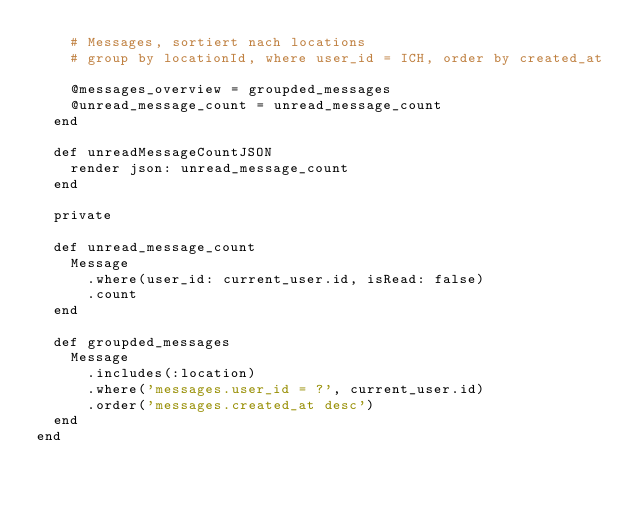<code> <loc_0><loc_0><loc_500><loc_500><_Ruby_>    # Messages, sortiert nach locations
    # group by locationId, where user_id = ICH, order by created_at

    @messages_overview = groupded_messages
    @unread_message_count = unread_message_count
  end

  def unreadMessageCountJSON
    render json: unread_message_count
  end

  private

  def unread_message_count
    Message
      .where(user_id: current_user.id, isRead: false)
      .count
  end

  def groupded_messages
    Message
      .includes(:location)
      .where('messages.user_id = ?', current_user.id)
      .order('messages.created_at desc')
  end
end
</code> 